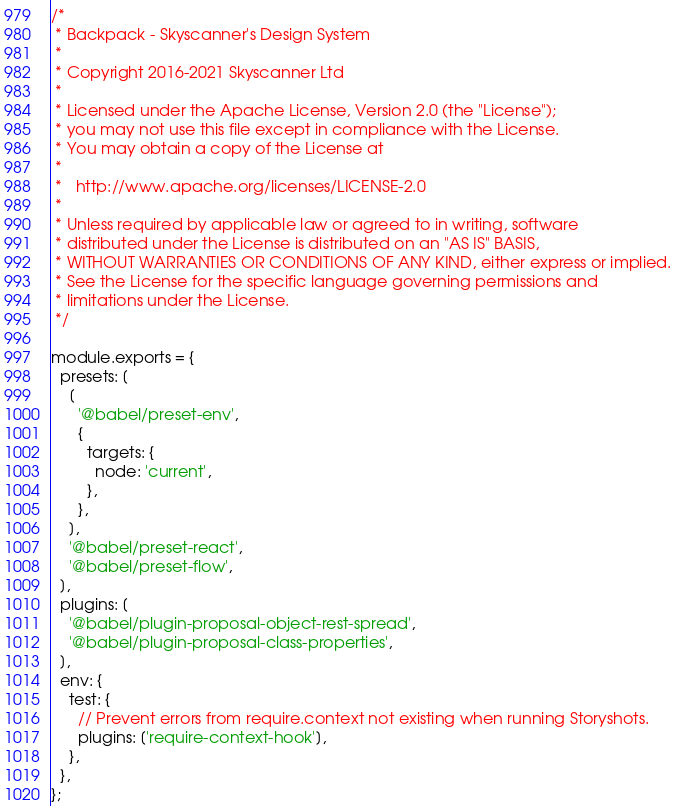Convert code to text. <code><loc_0><loc_0><loc_500><loc_500><_JavaScript_>/*
 * Backpack - Skyscanner's Design System
 *
 * Copyright 2016-2021 Skyscanner Ltd
 *
 * Licensed under the Apache License, Version 2.0 (the "License");
 * you may not use this file except in compliance with the License.
 * You may obtain a copy of the License at
 *
 *   http://www.apache.org/licenses/LICENSE-2.0
 *
 * Unless required by applicable law or agreed to in writing, software
 * distributed under the License is distributed on an "AS IS" BASIS,
 * WITHOUT WARRANTIES OR CONDITIONS OF ANY KIND, either express or implied.
 * See the License for the specific language governing permissions and
 * limitations under the License.
 */

module.exports = {
  presets: [
    [
      '@babel/preset-env',
      {
        targets: {
          node: 'current',
        },
      },
    ],
    '@babel/preset-react',
    '@babel/preset-flow',
  ],
  plugins: [
    '@babel/plugin-proposal-object-rest-spread',
    '@babel/plugin-proposal-class-properties',
  ],
  env: {
    test: {
      // Prevent errors from require.context not existing when running Storyshots.
      plugins: ['require-context-hook'],
    },
  },
};
</code> 